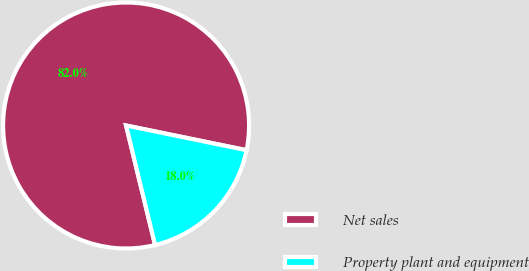<chart> <loc_0><loc_0><loc_500><loc_500><pie_chart><fcel>Net sales<fcel>Property plant and equipment<nl><fcel>82.01%<fcel>17.99%<nl></chart> 